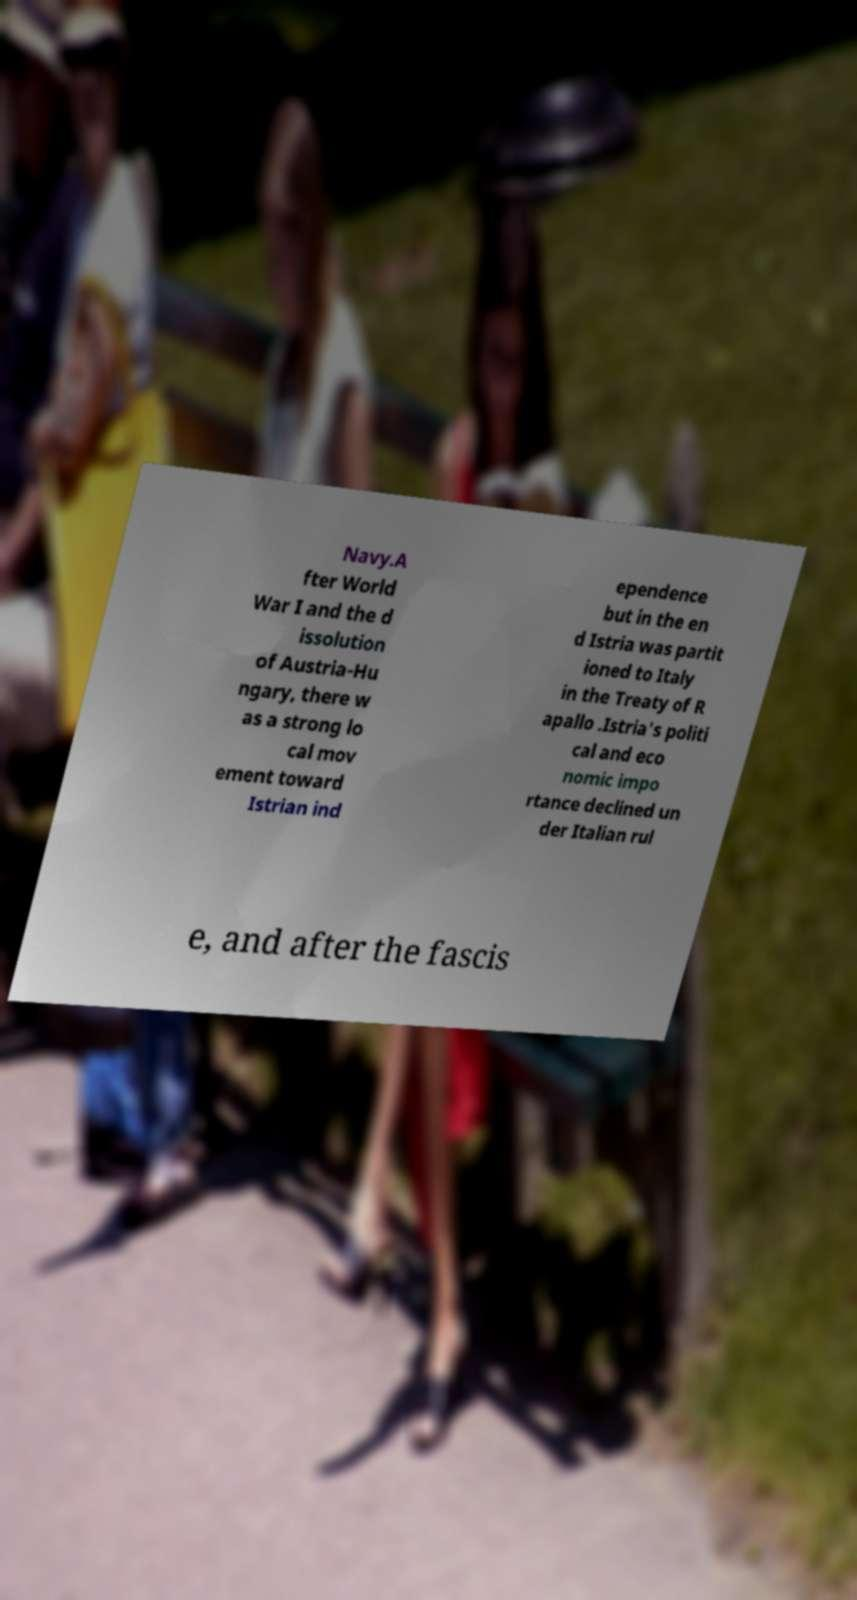Can you read and provide the text displayed in the image?This photo seems to have some interesting text. Can you extract and type it out for me? Navy.A fter World War I and the d issolution of Austria-Hu ngary, there w as a strong lo cal mov ement toward Istrian ind ependence but in the en d Istria was partit ioned to Italy in the Treaty of R apallo .Istria's politi cal and eco nomic impo rtance declined un der Italian rul e, and after the fascis 